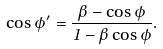<formula> <loc_0><loc_0><loc_500><loc_500>\cos \phi ^ { \prime } = \frac { \beta - \cos \phi } { 1 - \beta \cos \phi } .</formula> 